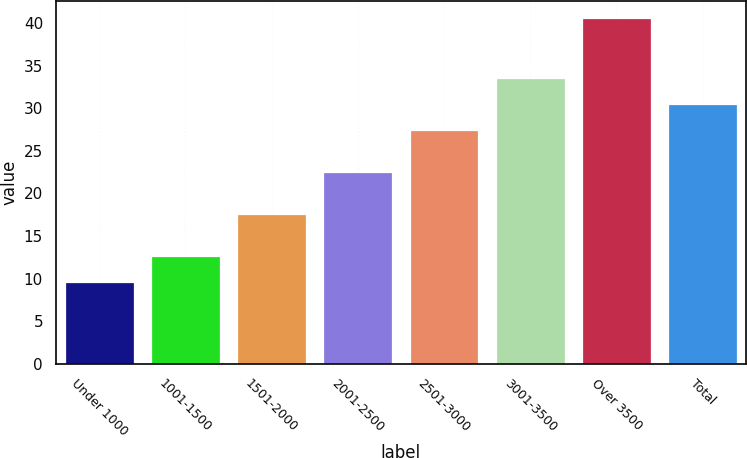Convert chart to OTSL. <chart><loc_0><loc_0><loc_500><loc_500><bar_chart><fcel>Under 1000<fcel>1001-1500<fcel>1501-2000<fcel>2001-2500<fcel>2501-3000<fcel>3001-3500<fcel>Over 3500<fcel>Total<nl><fcel>9.57<fcel>12.67<fcel>17.56<fcel>22.49<fcel>27.4<fcel>33.6<fcel>40.57<fcel>30.5<nl></chart> 